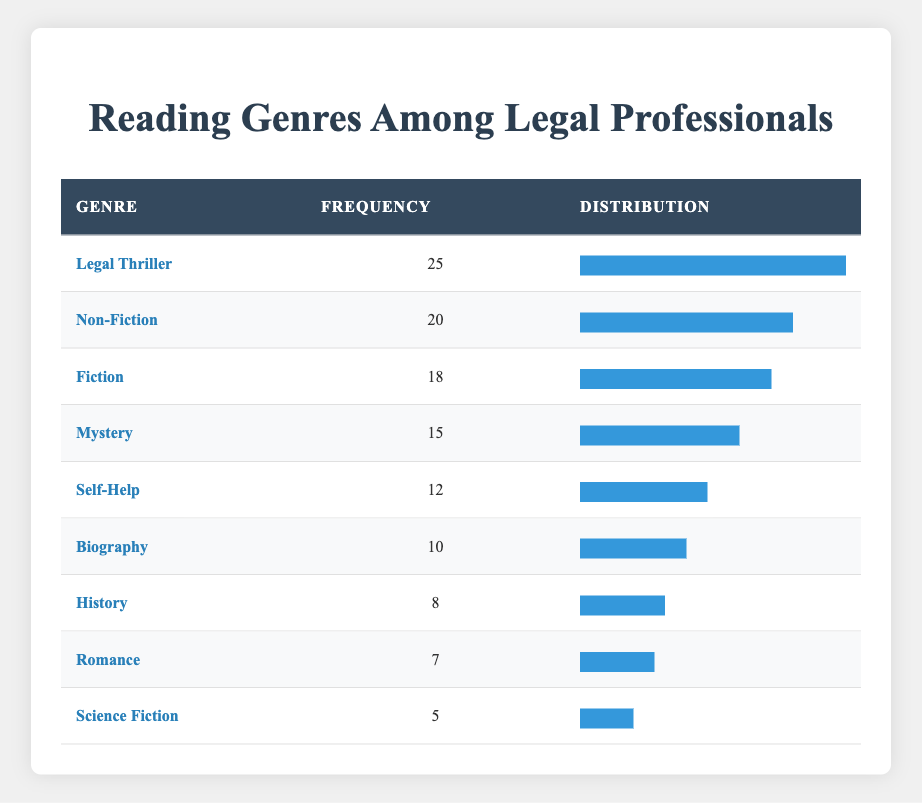What genre has the highest frequency? In the table, we can see that "Legal Thriller" has the highest frequency, listed with a value of 25.
Answer: Legal Thriller How many professionals read "Biography"? The table indicates that 10 professionals read the genre "Biography."
Answer: 10 What is the total frequency of genres that are Fiction-related (Fiction and Mystery)? To find this, we add the frequencies: Fiction (18) + Mystery (15) = 33.
Answer: 33 Is "Science Fiction" the least read genre? According to the table, "Science Fiction" has a frequency of 5, which is lower than all other genres. Therefore, it is indeed the least read genre.
Answer: Yes What is the average frequency of genres read by legal professionals? To compute the average, we first sum all frequencies: 25 + 20 + 18 + 15 + 12 + 10 + 8 + 7 + 5 = 120. There are 9 genres, so we divide 120 by 9, which gives us 13.33 (rounded).
Answer: Approximately 13.33 How many genres have a frequency greater than 15? By examining the table, we count the genres: Legal Thriller (25), Non-Fiction (20), Fiction (18), and Mystery (15), resulting in four genres that have frequencies greater than 15.
Answer: 4 What percentage of professionals read "Self-Help" compared to the total? The total frequency of all genres is 120, and "Self-Help" has a frequency of 12. To find the percentage, we calculate (12/120) * 100 = 10%.
Answer: 10% Which genres have a frequency of less than 10? Looking at the table, only the "Science Fiction" genre has a frequency of 5, which is the only one below 10. Therefore, it is the only genre that fits this criterion.
Answer: Science Fiction Which genre has the second highest frequency, and how many read it? The second highest frequency is held by "Non-Fiction" with a value of 20. This can be identified by comparing the frequencies after the highest one.
Answer: Non-Fiction, 20 